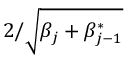Convert formula to latex. <formula><loc_0><loc_0><loc_500><loc_500>2 / \sqrt { \beta _ { j } + \beta _ { j - 1 } ^ { * } }</formula> 